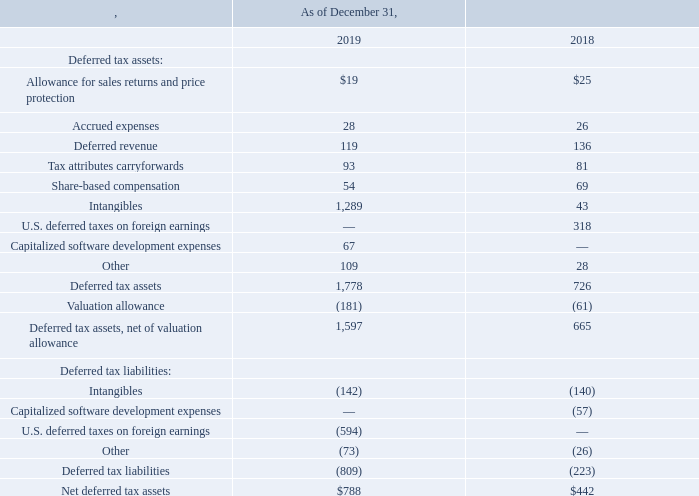Deferred income taxes reflect the net tax effects of temporary differences between the amounts of assets and liabilities for accounting purposes and the amounts used for income tax purposes. The components of the net deferred tax assets (liabilities) are as follows (amounts in millions):
As of December 31, 2019, we had gross tax credit carryforwards of $191 million for state purposes. The tax credit carryforwards are included in Deferred tax assets net of unrealized tax benefits that would apply upon the realization of uncertain tax positions. In addition, we had foreign NOL carryforwards of $32 million at December 31, 2019, attributed mainly to losses in France which can be carried forward indefinitely.
We evaluate deferred tax assets each period for recoverability. We record a valuation allowance for assets that do not meet the threshold of “more likely than not” to be realized in the future. To make that determination, we evaluate the likelihood of realization based on the weight of all positive and negative evidence available. As a result of the Closing Agreement, we received in 2018, we determined at that time that our remaining California research and development credit carryforwards (“CA R&D Credit”) no longer met the threshold of more likely than not to be realized in the future. As such, consistent with our position at December 31, 2018, we have established a full valuation allowance against our CA R&D Credit. For the year ended December 31, 2019, the valuation allowance related to our CA R&D Credit is $71 million. We will reassess this determination quarterly and record a tax benefit if and when future evidence allows for a partial or full release of this valuation allowance.
As of December 31, 2017, we no longer consider the available cash balances related to undistributed earnings held outside of the U.S. by our foreign subsidiaries to be indefinitely reinvested.
What was the amount of gross tax credit carryforwards for state purposes in 2019? $191 million. What was the deferred revenue in 2019?
Answer scale should be: million. 119. What was the accrued expenses in 2018?
Answer scale should be: million. 26. What was the percentage change in accrued expenses between 2018 and 2019?
Answer scale should be: percent. (28-26)/26
Answer: 7.69. What was the percentage change in intangibles between 2018 and 2019?
Answer scale should be: percent. (1,289-43)/43
Answer: 2897.67. What was the change in net deferred tax assets between 2018 and 2019?
Answer scale should be: million. ($788-$442)
Answer: 346. 